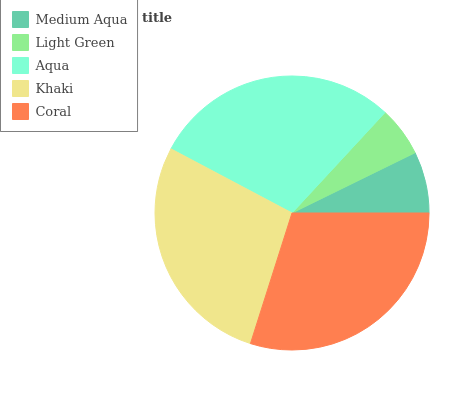Is Light Green the minimum?
Answer yes or no. Yes. Is Coral the maximum?
Answer yes or no. Yes. Is Aqua the minimum?
Answer yes or no. No. Is Aqua the maximum?
Answer yes or no. No. Is Aqua greater than Light Green?
Answer yes or no. Yes. Is Light Green less than Aqua?
Answer yes or no. Yes. Is Light Green greater than Aqua?
Answer yes or no. No. Is Aqua less than Light Green?
Answer yes or no. No. Is Khaki the high median?
Answer yes or no. Yes. Is Khaki the low median?
Answer yes or no. Yes. Is Light Green the high median?
Answer yes or no. No. Is Aqua the low median?
Answer yes or no. No. 